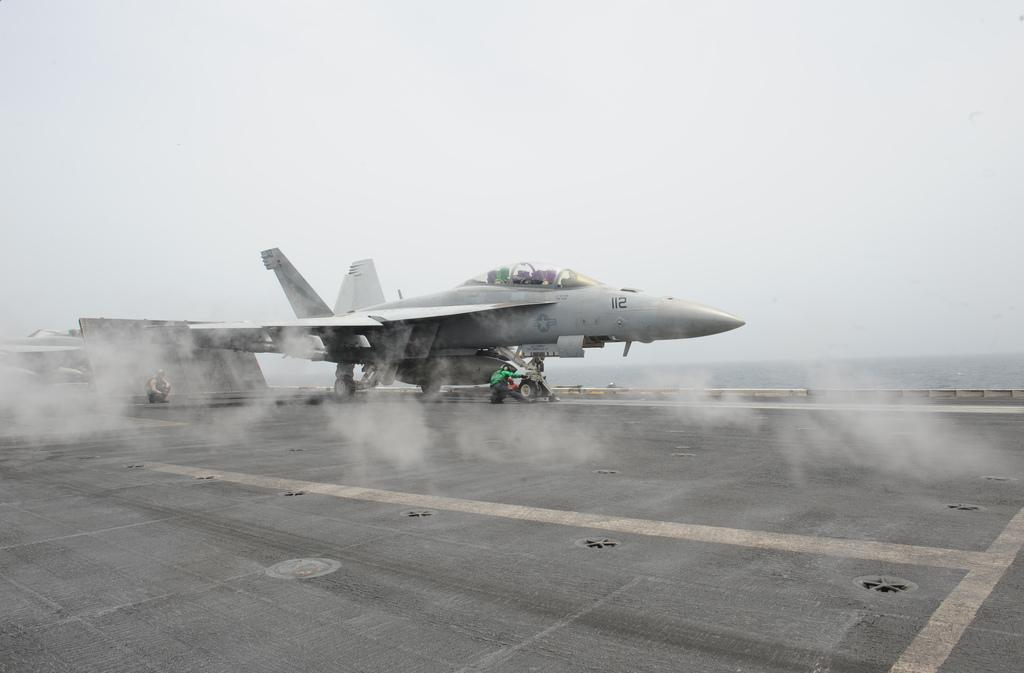What is the main subject of the image? The main subject of the image is a space jet on the runway. What can be seen in the background of the image? The sky is visible in the background of the image. Are there any people present in the image? Yes, there are people present in the image. What type of control panel can be seen in the image? There is no control panel present in the image; it features a space jet on the runway and people. What stage of development is the space jet in the image? The image does not provide information about the development stage of the space jet. 